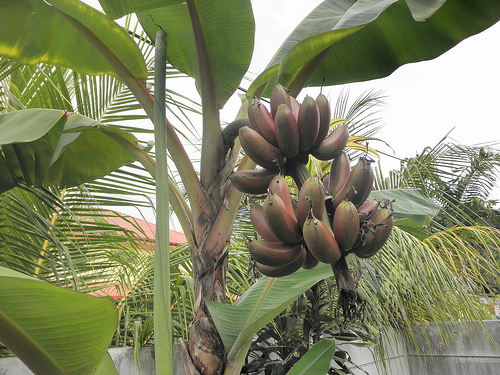<image>
Is there a leaf above the sky? No. The leaf is not positioned above the sky. The vertical arrangement shows a different relationship. 